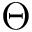Convert formula to latex. <formula><loc_0><loc_0><loc_500><loc_500>\Theta</formula> 